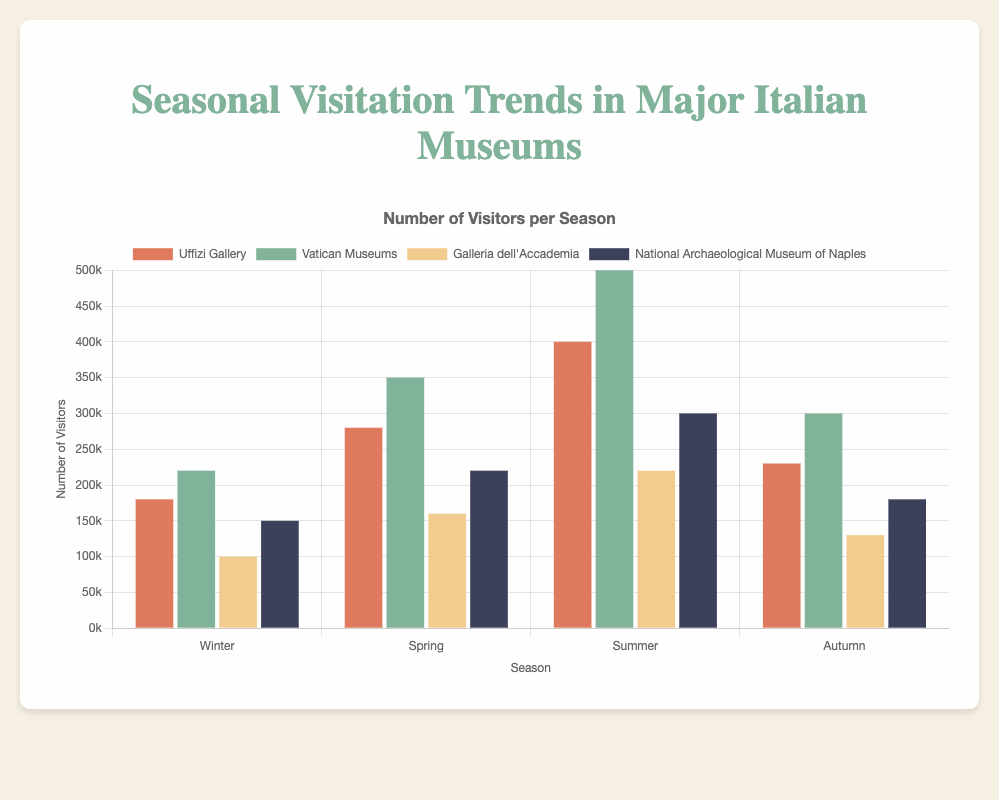What season sees the highest number of visitors at the Uffizi Gallery? The height of the bars for the Uffizi Gallery needs to be compared across seasons: Winter (180,000), Spring (280,000), Summer (400,000), and Autumn (230,000). The Summer bar is the tallest, showing 400,000 visitors.
Answer: Summer How many more visitors does the Vatican Museums get in Spring compared to Galleria dell'Accademia? Find the difference between the Vatican Museums' Spring visitors (350,000) and Galleria dell'Accademia's Spring visitors (160,000): 350,000 - 160,000 = 190,000.
Answer: 190,000 Which season has the least visitors at the National Archaeological Museum of Naples? The height of the bars for the National Archaeological Museum of Naples needs to be compared: Winter (150,000), Spring (220,000), Summer (300,000), and Autumn (180,000). The Winter bar is the shortest, showing 150,000 visitors.
Answer: Winter Is there any season where both the Uffizi Gallery and Vatican Museums have their peak visitors? Compare the heights of the bars for all seasons at both the Uffizi Gallery and Vatican Museums. The peaks for Uffizi Gallery and Vatican Museums are in Summer (400,000 and 500,000 respectively).
Answer: Yes, Summer What is the total number of visitors for Galleria dell'Accademia across all seasons? Sum the visitor numbers for Galleria dell'Accademia: Winter (100,000) + Spring (160,000) + Summer (220,000) + Autumn (130,000): 100,000 + 160,000 + 220,000 + 130,000 = 610,000.
Answer: 610,000 Which museum has the most considerable seasonal variation in visitors, and what is the difference between its highest and lowest seasons? Identify the minimum and maximum visitors for each museum and find the range. For Uffizi Gallery: 400,000 (Summer) - 180,000 (Winter) = 220,000. For Vatican Museums: 500,000 (Summer) - 220,000 (Winter) = 280,000. For Galleria dell'Accademia: 220,000 (Summer) - 100,000 (Winter) = 120,000. For National Archaeological Museum of Naples: 300,000 (Summer) - 150,000 (Winter) = 150,000. The Vatican Museums show the most considerable variation: 280,000.
Answer: Vatican Museums, 280,000 Is there any season where all museums have an increase in visitors from the previous season? Compare the visitor numbers across seasons for each museum. For all museums, transitioning from Winter to Spring shows an increase: Uffizi Gallery (180,000 -> 280,000), Vatican Museums (220,000 -> 350,000), Galleria dell'Accademia (100,000 -> 160,000), National Archaeological Museum of Naples (150,000 -> 220,000).
Answer: Spring 